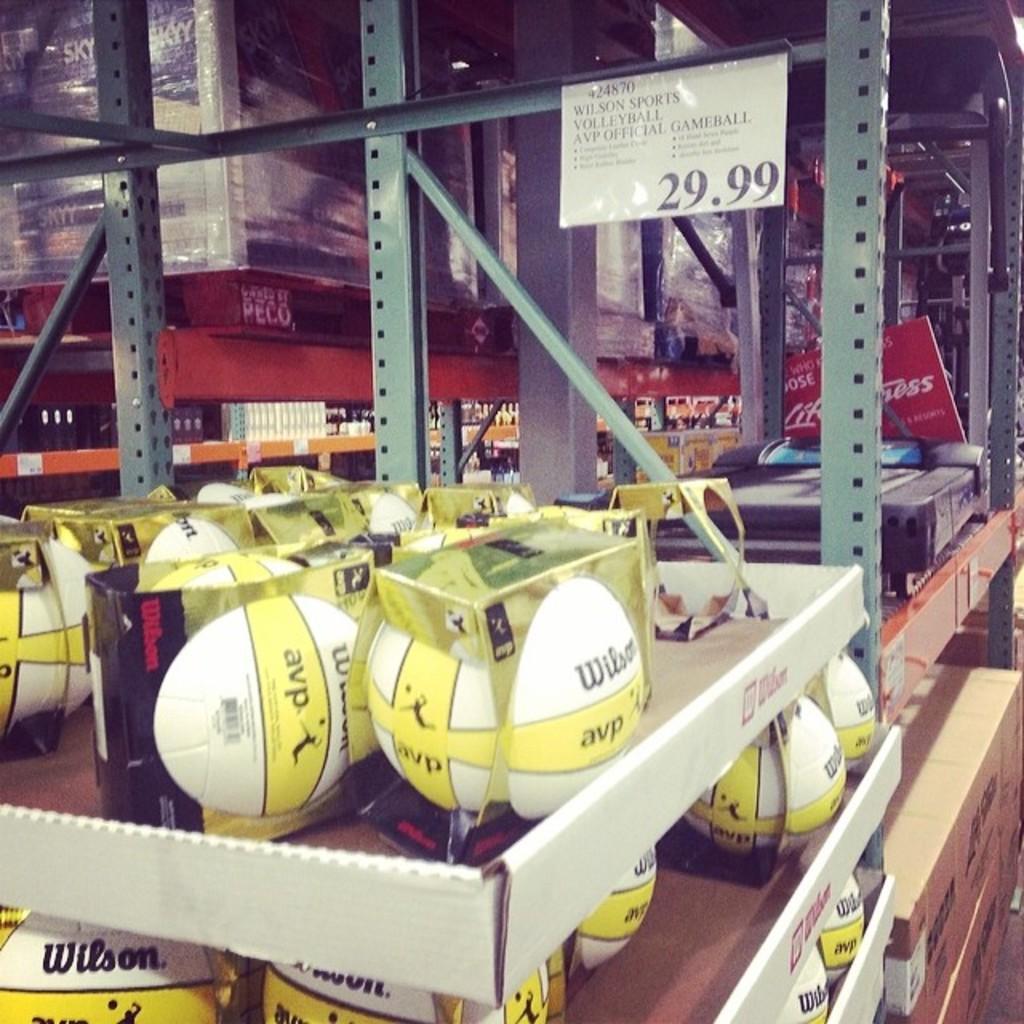Can you describe this image briefly? In this picture I can observe white color balls placed in the racks. On the right side I can observe a name board. There is some text on this white color board. In the background I can observe some books which are in brown color. 